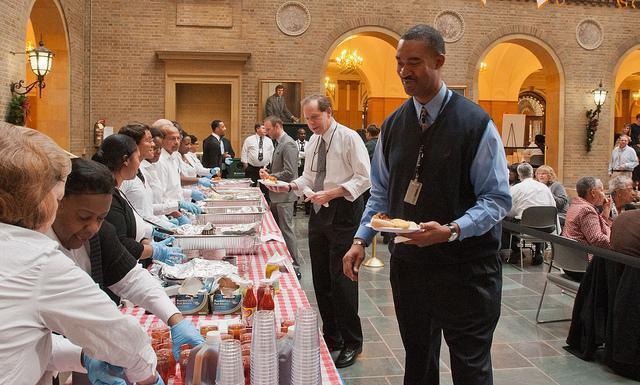Why should they wear gloves?
Select the correct answer and articulate reasoning with the following format: 'Answer: answer
Rationale: rationale.'
Options: Cold weather, identifying themselves, hygiene, fashion. Answer: hygiene.
Rationale: These plastic gloves protect food from germs 